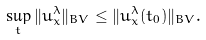Convert formula to latex. <formula><loc_0><loc_0><loc_500><loc_500>\sup _ { t } \| u ^ { \lambda } _ { x } \| _ { B V } \leq \| u ^ { \lambda } _ { x } ( t _ { 0 } ) \| _ { B V } .</formula> 